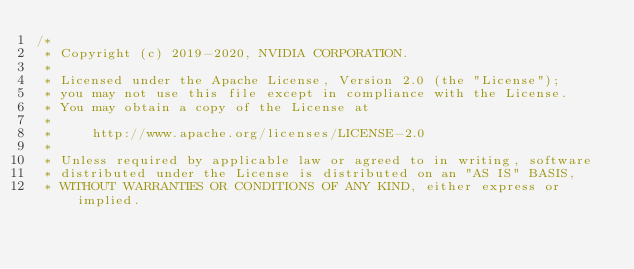Convert code to text. <code><loc_0><loc_0><loc_500><loc_500><_Cuda_>/*
 * Copyright (c) 2019-2020, NVIDIA CORPORATION.
 *
 * Licensed under the Apache License, Version 2.0 (the "License");
 * you may not use this file except in compliance with the License.
 * You may obtain a copy of the License at
 *
 *     http://www.apache.org/licenses/LICENSE-2.0
 *
 * Unless required by applicable law or agreed to in writing, software
 * distributed under the License is distributed on an "AS IS" BASIS,
 * WITHOUT WARRANTIES OR CONDITIONS OF ANY KIND, either express or implied.</code> 